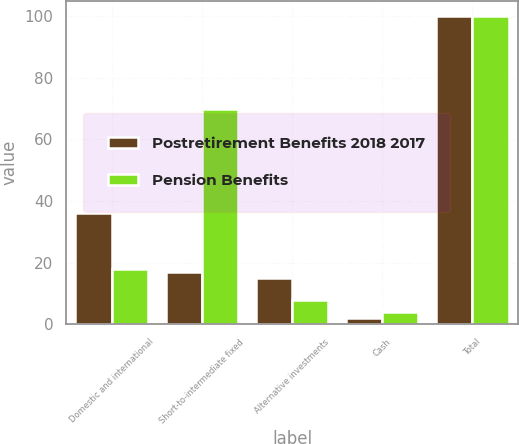Convert chart to OTSL. <chart><loc_0><loc_0><loc_500><loc_500><stacked_bar_chart><ecel><fcel>Domestic and international<fcel>Short-to-intermediate fixed<fcel>Alternative investments<fcel>Cash<fcel>Total<nl><fcel>Postretirement Benefits 2018 2017<fcel>36<fcel>17<fcel>15<fcel>2<fcel>100<nl><fcel>Pension Benefits<fcel>18<fcel>70<fcel>8<fcel>4<fcel>100<nl></chart> 